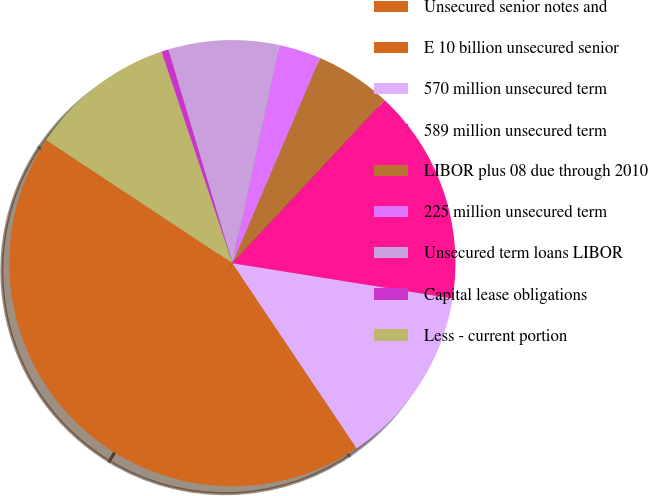Convert chart. <chart><loc_0><loc_0><loc_500><loc_500><pie_chart><fcel>Unsecured senior notes and<fcel>E 10 billion unsecured senior<fcel>570 million unsecured term<fcel>589 million unsecured term<fcel>LIBOR plus 08 due through 2010<fcel>225 million unsecured term<fcel>Unsecured term loans LIBOR<fcel>Capital lease obligations<fcel>Less - current portion<nl><fcel>25.62%<fcel>18.08%<fcel>13.06%<fcel>15.57%<fcel>5.53%<fcel>3.02%<fcel>8.04%<fcel>0.51%<fcel>10.55%<nl></chart> 